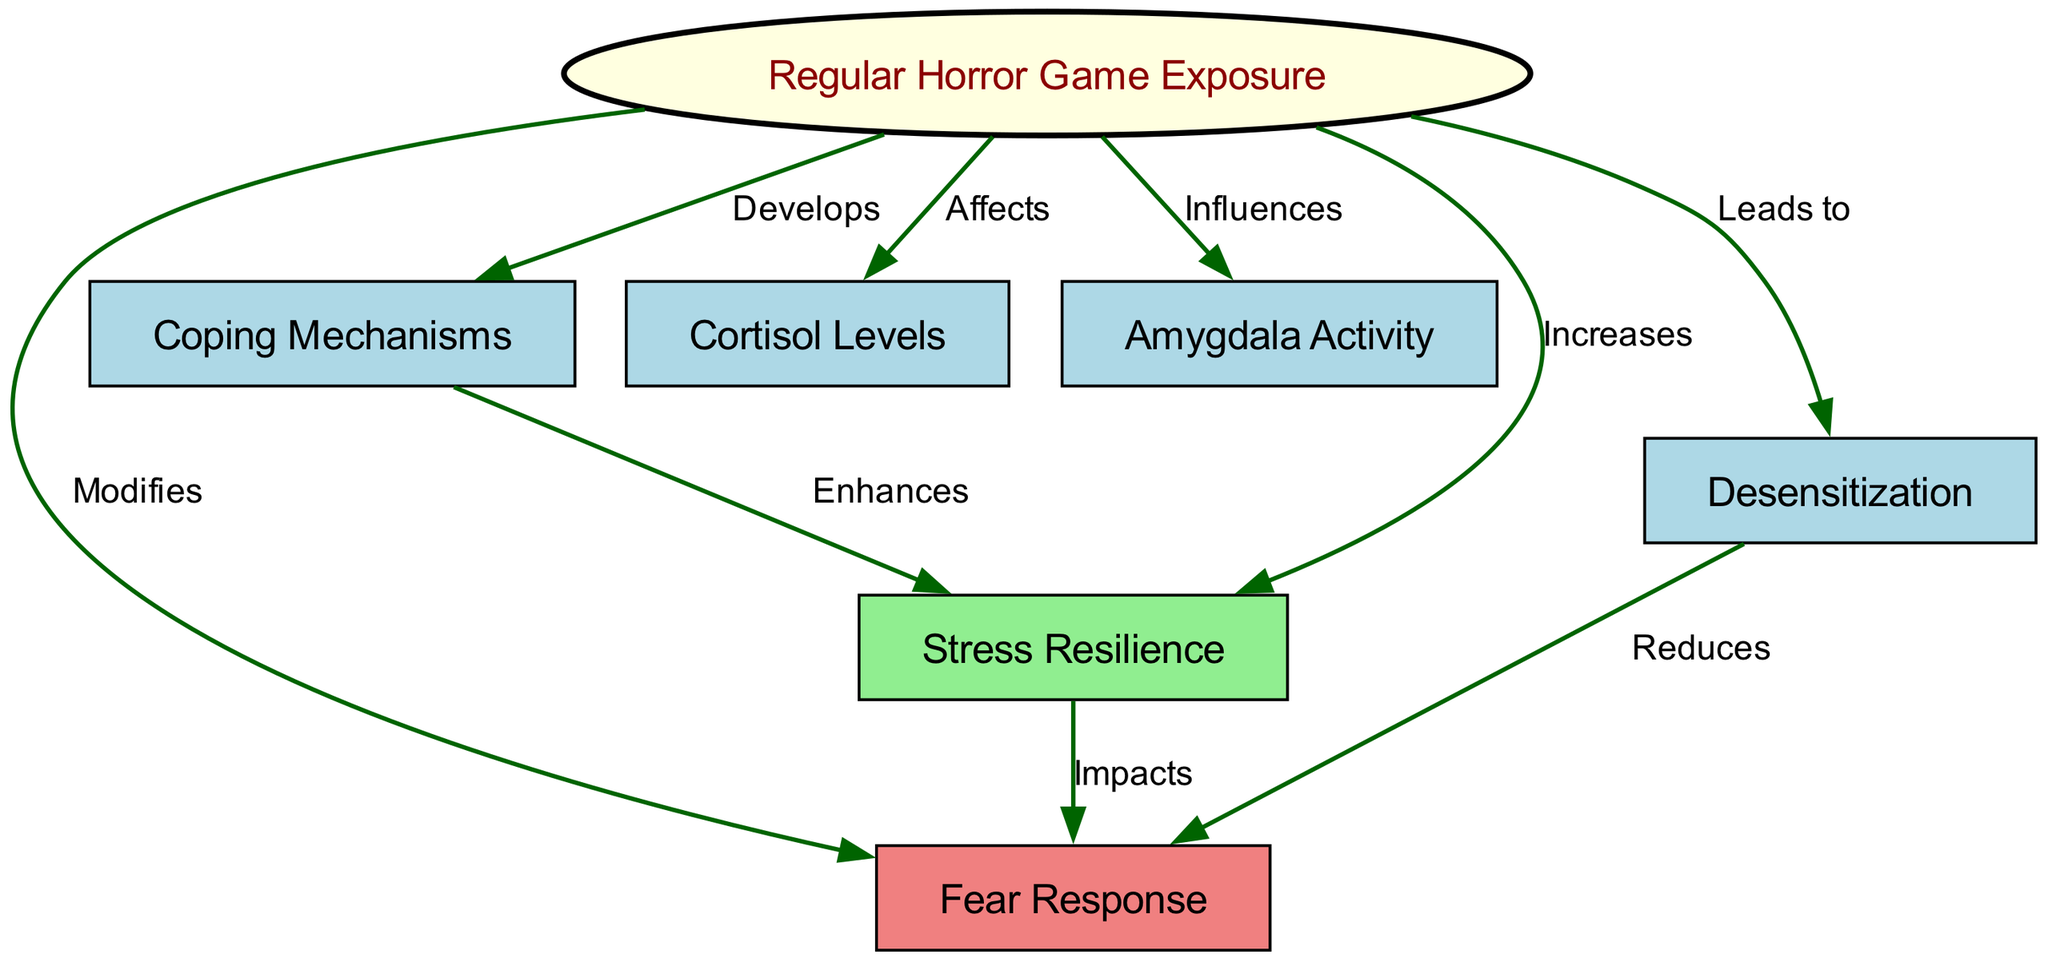What is the main node representing the subject of the diagram? The main node is labeled "Regular Horror Game Exposure," which is central to the relationships shown in the diagram.
Answer: Regular Horror Game Exposure How many nodes are present in the diagram? By counting the labeled circles, we see there are 7 nodes total.
Answer: 7 What type of relationship exists between "Regular Horror Game Exposure" and "Stress Resilience"? The relationship is labeled "Increases," indicating that regular exposure enhances stress resilience according to the diagram.
Answer: Increases Which node is influenced by "Regular Horror Game Exposure" that relates to emotional response? The node is "Fear Response," showing that exposure modifies fear reactions in the individual.
Answer: Fear Response What does "Desensitization" lead to in terms of fear response? The relationship is labeled "Reduces," indicating that increased desensitization lessens fear reactions according to the diagram.
Answer: Reduces How does "Coping Mechanisms" relate to "Stress Resilience"? The connection is labeled "Enhances," showing that effective coping mechanisms improve stress resilience.
Answer: Enhances What effect does "Regular Horror Game Exposure" have on "Cortisol Levels"? It is labeled "Affects," indicating that exposure has a direct impact on cortisol levels, a stress hormone.
Answer: Affects Which node shows a direct relationship with "Amygdala Activity"? The node is "Regular Horror Game Exposure," which influences the amygdala's functioning in fear processing.
Answer: Regular Horror Game Exposure What impact does "Stress Resilience" have on "Fear Response"? The relationship is labeled "Impacts," showing that higher stress resilience can lead to changes in fear responses.
Answer: Impacts 